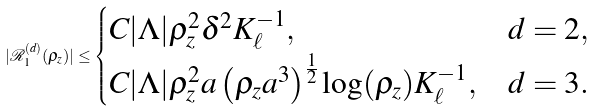Convert formula to latex. <formula><loc_0><loc_0><loc_500><loc_500>| \mathcal { R } _ { 1 } ^ { ( d ) } ( \rho _ { z } ) | \leq \begin{cases} C | \Lambda | \rho _ { z } ^ { 2 } \delta ^ { 2 } K _ { \ell } ^ { - 1 } , & d = 2 , \\ C | \Lambda | \rho _ { z } ^ { 2 } a \left ( \rho _ { z } a ^ { 3 } \right ) ^ { \frac { 1 } { 2 } } \log ( \rho _ { z } ) K _ { \ell } ^ { - 1 } , & d = 3 . \end{cases}</formula> 